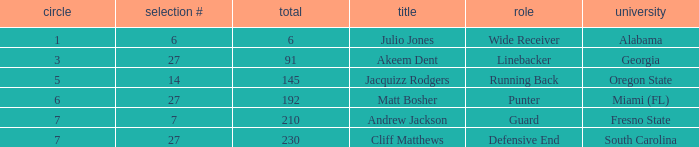Which highest pick number had Akeem Dent as a name and where the overall was less than 91? None. Can you give me this table as a dict? {'header': ['circle', 'selection #', 'total', 'title', 'role', 'university'], 'rows': [['1', '6', '6', 'Julio Jones', 'Wide Receiver', 'Alabama'], ['3', '27', '91', 'Akeem Dent', 'Linebacker', 'Georgia'], ['5', '14', '145', 'Jacquizz Rodgers', 'Running Back', 'Oregon State'], ['6', '27', '192', 'Matt Bosher', 'Punter', 'Miami (FL)'], ['7', '7', '210', 'Andrew Jackson', 'Guard', 'Fresno State'], ['7', '27', '230', 'Cliff Matthews', 'Defensive End', 'South Carolina']]} 